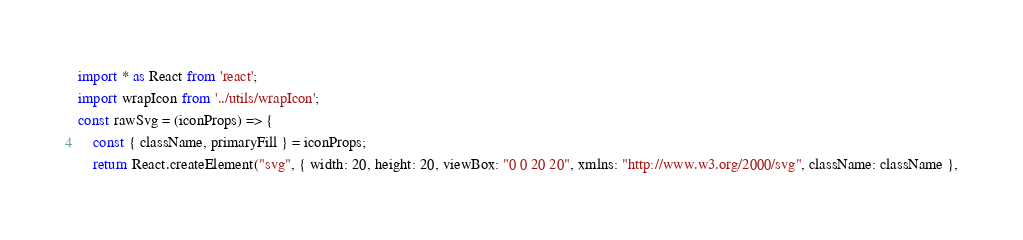Convert code to text. <code><loc_0><loc_0><loc_500><loc_500><_JavaScript_>import * as React from 'react';
import wrapIcon from '../utils/wrapIcon';
const rawSvg = (iconProps) => {
    const { className, primaryFill } = iconProps;
    return React.createElement("svg", { width: 20, height: 20, viewBox: "0 0 20 20", xmlns: "http://www.w3.org/2000/svg", className: className },</code> 